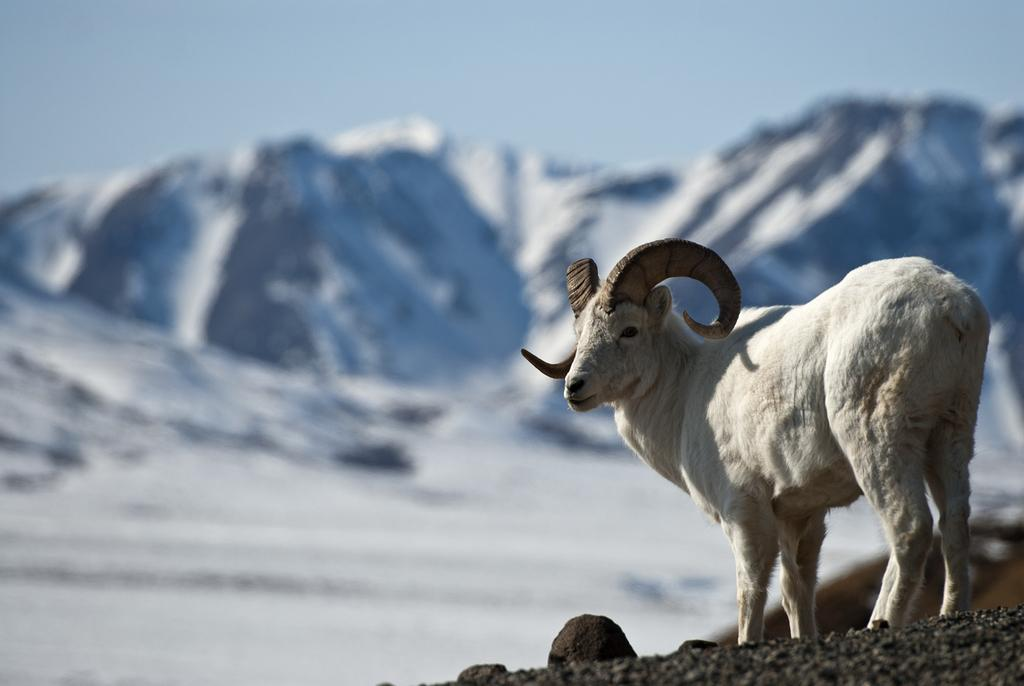What animal is present in the image? There is a goat in the image. What is the color of the goat? The goat is white in color. What can be seen in the background of the image? There is a sky and hills visible in the background of the image. How many eyes does the giraffe have in the image? There is no giraffe present in the image, so it is not possible to determine the number of eyes it might have. 